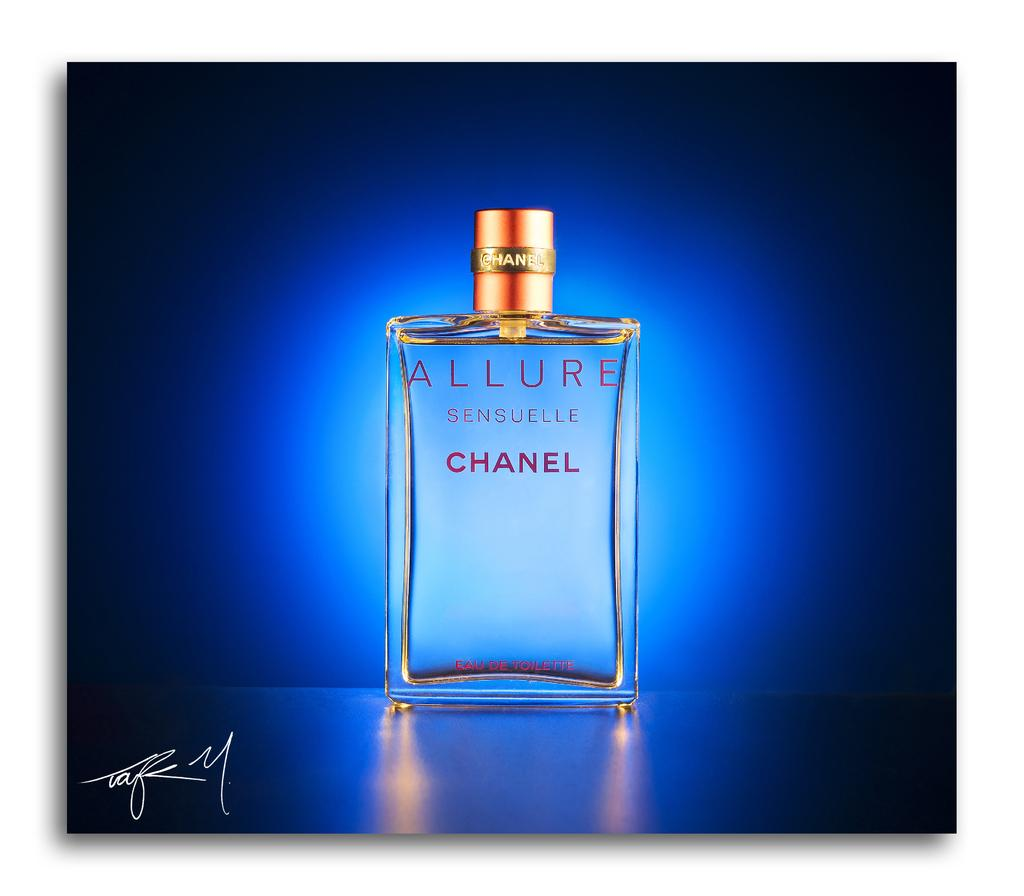<image>
Summarize the visual content of the image. A bottle of Chanel perfume called Allure against a blue backdrop. 